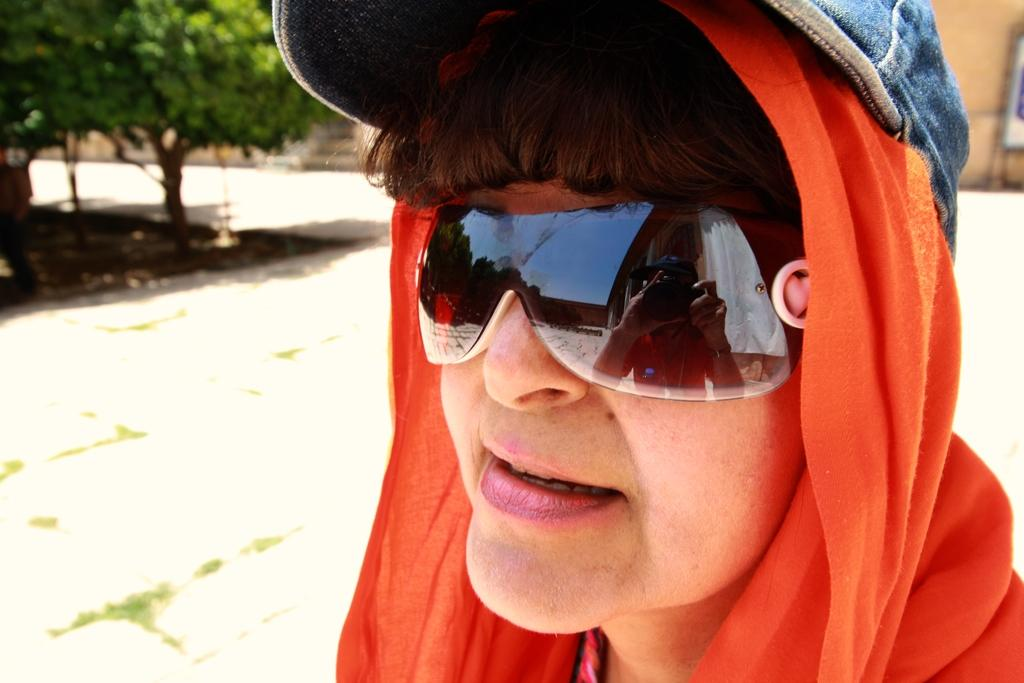Who is present in the image? There is a woman in the image. What is the woman wearing on her head? The woman is wearing a cap. What is the woman wearing to protect her eyes? The woman is wearing goggles. What type of vegetation can be seen in the image? There are trees in the left corner of the image. What else can be seen in the background of the image? There are other objects in the background of the image. What type of stick is the woman holding in the image? The woman is not holding a stick in the image. How much dust can be seen on the trees in the image? The image does not show any dust on the trees. 